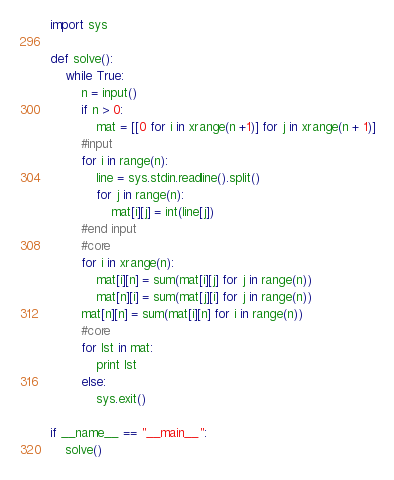<code> <loc_0><loc_0><loc_500><loc_500><_Python_>import sys

def solve():
    while True:
        n = input()
        if n > 0:
            mat = [[0 for i in xrange(n +1)] for j in xrange(n + 1)]
        #input
        for i in range(n):
            line = sys.stdin.readline().split()
            for j in range(n):
                mat[i][j] = int(line[j])        
        #end input
        #core
        for i in xrange(n):
            mat[i][n] = sum(mat[i][j] for j in range(n))
            mat[n][i] = sum(mat[j][i] for j in range(n))
        mat[n][n] = sum(mat[i][n] for i in range(n))
        #core
        for lst in mat:
            print lst
        else:
            sys.exit()

if __name__ == "__main__":
    solve()</code> 